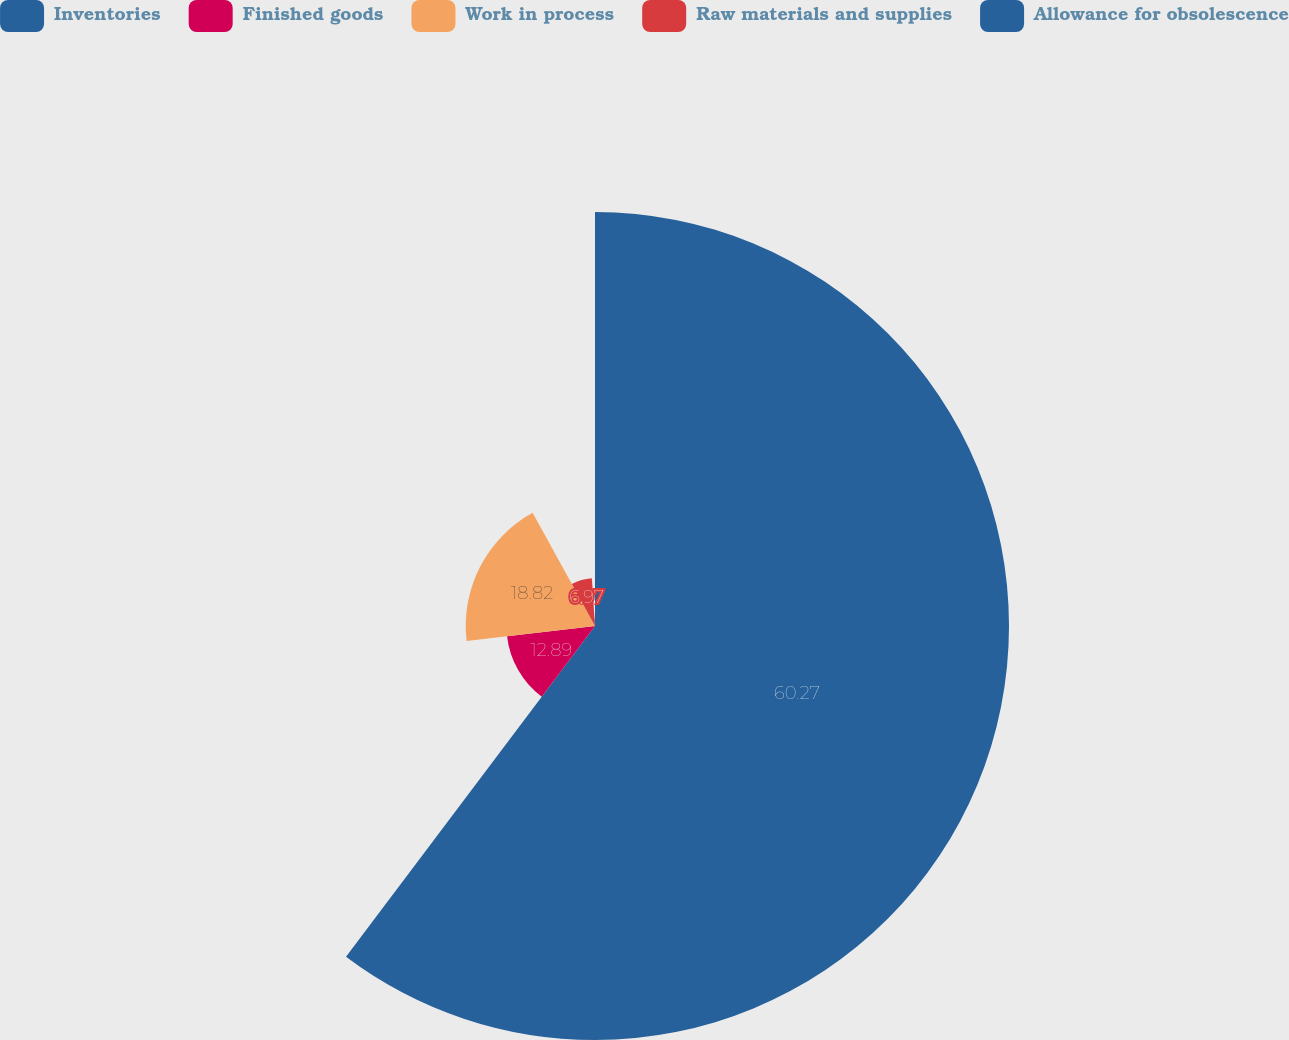Convert chart. <chart><loc_0><loc_0><loc_500><loc_500><pie_chart><fcel>Inventories<fcel>Finished goods<fcel>Work in process<fcel>Raw materials and supplies<fcel>Allowance for obsolescence<nl><fcel>60.27%<fcel>12.89%<fcel>18.82%<fcel>6.97%<fcel>1.05%<nl></chart> 